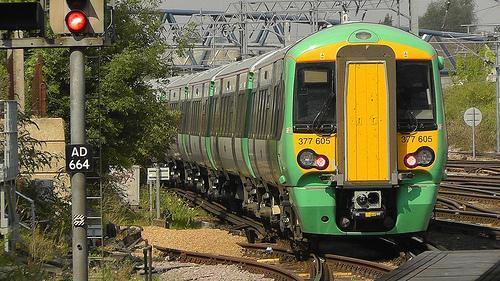How many trains are there?
Give a very brief answer. 1. How many lights on the engine?
Give a very brief answer. 4. 